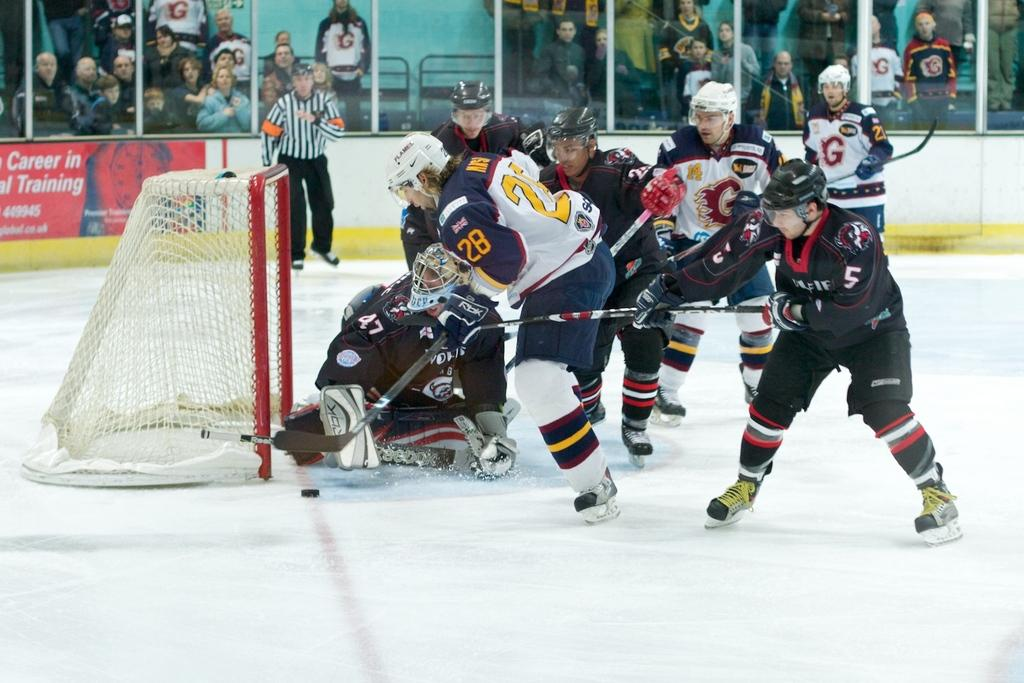<image>
Provide a brief description of the given image. Hockey game in action that has a sign for career in training on the wall. 